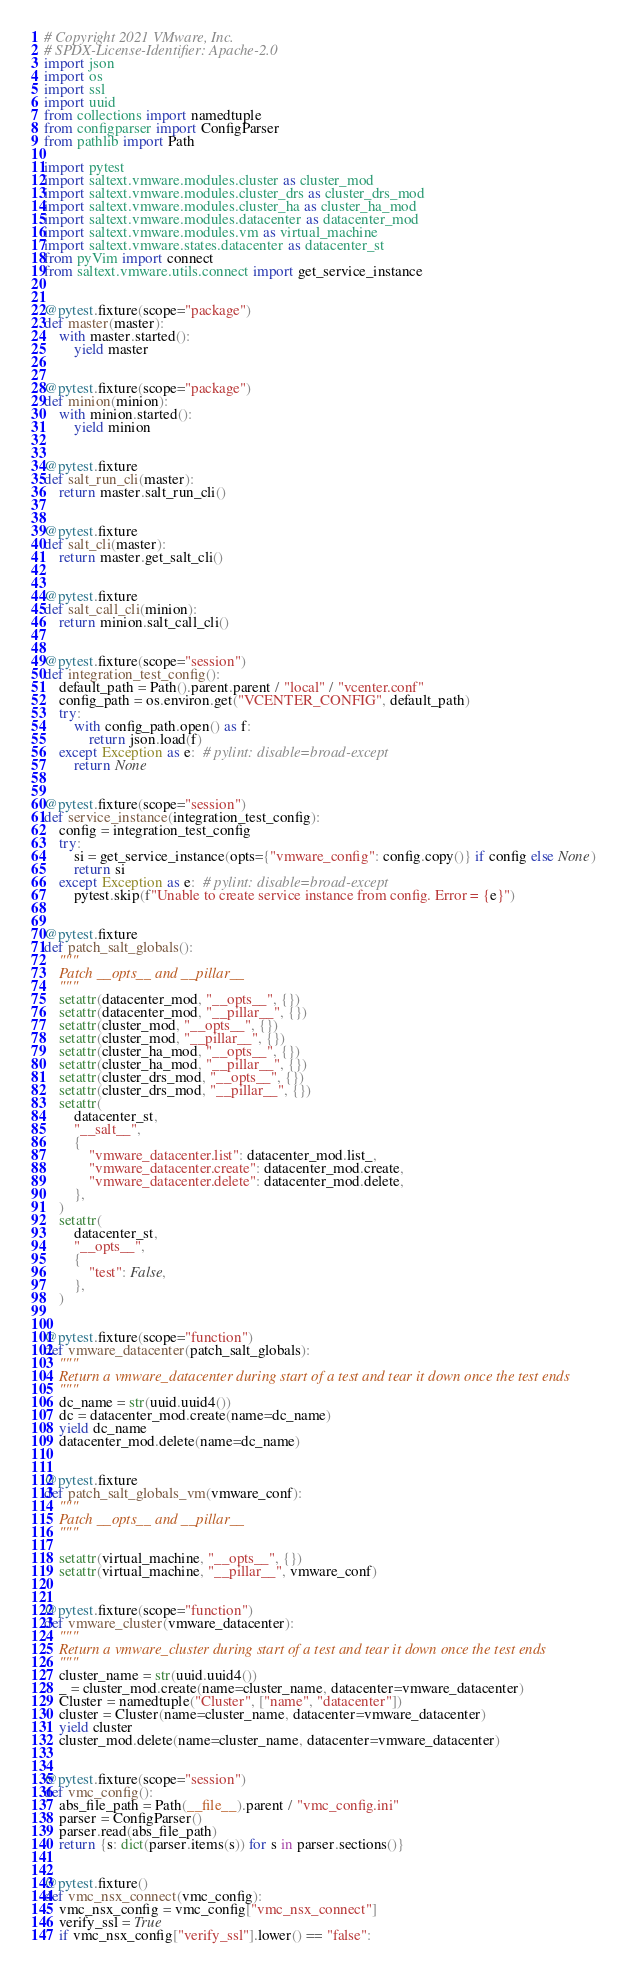<code> <loc_0><loc_0><loc_500><loc_500><_Python_># Copyright 2021 VMware, Inc.
# SPDX-License-Identifier: Apache-2.0
import json
import os
import ssl
import uuid
from collections import namedtuple
from configparser import ConfigParser
from pathlib import Path

import pytest
import saltext.vmware.modules.cluster as cluster_mod
import saltext.vmware.modules.cluster_drs as cluster_drs_mod
import saltext.vmware.modules.cluster_ha as cluster_ha_mod
import saltext.vmware.modules.datacenter as datacenter_mod
import saltext.vmware.modules.vm as virtual_machine
import saltext.vmware.states.datacenter as datacenter_st
from pyVim import connect
from saltext.vmware.utils.connect import get_service_instance


@pytest.fixture(scope="package")
def master(master):
    with master.started():
        yield master


@pytest.fixture(scope="package")
def minion(minion):
    with minion.started():
        yield minion


@pytest.fixture
def salt_run_cli(master):
    return master.salt_run_cli()


@pytest.fixture
def salt_cli(master):
    return master.get_salt_cli()


@pytest.fixture
def salt_call_cli(minion):
    return minion.salt_call_cli()


@pytest.fixture(scope="session")
def integration_test_config():
    default_path = Path().parent.parent / "local" / "vcenter.conf"
    config_path = os.environ.get("VCENTER_CONFIG", default_path)
    try:
        with config_path.open() as f:
            return json.load(f)
    except Exception as e:  # pylint: disable=broad-except
        return None


@pytest.fixture(scope="session")
def service_instance(integration_test_config):
    config = integration_test_config
    try:
        si = get_service_instance(opts={"vmware_config": config.copy()} if config else None)
        return si
    except Exception as e:  # pylint: disable=broad-except
        pytest.skip(f"Unable to create service instance from config. Error = {e}")


@pytest.fixture
def patch_salt_globals():
    """
    Patch __opts__ and __pillar__
    """
    setattr(datacenter_mod, "__opts__", {})
    setattr(datacenter_mod, "__pillar__", {})
    setattr(cluster_mod, "__opts__", {})
    setattr(cluster_mod, "__pillar__", {})
    setattr(cluster_ha_mod, "__opts__", {})
    setattr(cluster_ha_mod, "__pillar__", {})
    setattr(cluster_drs_mod, "__opts__", {})
    setattr(cluster_drs_mod, "__pillar__", {})
    setattr(
        datacenter_st,
        "__salt__",
        {
            "vmware_datacenter.list": datacenter_mod.list_,
            "vmware_datacenter.create": datacenter_mod.create,
            "vmware_datacenter.delete": datacenter_mod.delete,
        },
    )
    setattr(
        datacenter_st,
        "__opts__",
        {
            "test": False,
        },
    )


@pytest.fixture(scope="function")
def vmware_datacenter(patch_salt_globals):
    """
    Return a vmware_datacenter during start of a test and tear it down once the test ends
    """
    dc_name = str(uuid.uuid4())
    dc = datacenter_mod.create(name=dc_name)
    yield dc_name
    datacenter_mod.delete(name=dc_name)


@pytest.fixture
def patch_salt_globals_vm(vmware_conf):
    """
    Patch __opts__ and __pillar__
    """

    setattr(virtual_machine, "__opts__", {})
    setattr(virtual_machine, "__pillar__", vmware_conf)


@pytest.fixture(scope="function")
def vmware_cluster(vmware_datacenter):
    """
    Return a vmware_cluster during start of a test and tear it down once the test ends
    """
    cluster_name = str(uuid.uuid4())
    _ = cluster_mod.create(name=cluster_name, datacenter=vmware_datacenter)
    Cluster = namedtuple("Cluster", ["name", "datacenter"])
    cluster = Cluster(name=cluster_name, datacenter=vmware_datacenter)
    yield cluster
    cluster_mod.delete(name=cluster_name, datacenter=vmware_datacenter)


@pytest.fixture(scope="session")
def vmc_config():
    abs_file_path = Path(__file__).parent / "vmc_config.ini"
    parser = ConfigParser()
    parser.read(abs_file_path)
    return {s: dict(parser.items(s)) for s in parser.sections()}


@pytest.fixture()
def vmc_nsx_connect(vmc_config):
    vmc_nsx_config = vmc_config["vmc_nsx_connect"]
    verify_ssl = True
    if vmc_nsx_config["verify_ssl"].lower() == "false":</code> 